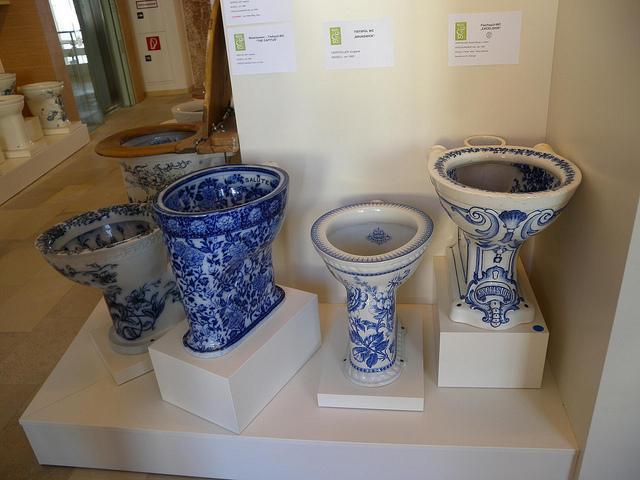Where would this style of porcelain item be found in a house?
Indicate the correct response by choosing from the four available options to answer the question.
Options: Kitchen, laundry room, bathroom, garage. Bathroom. 